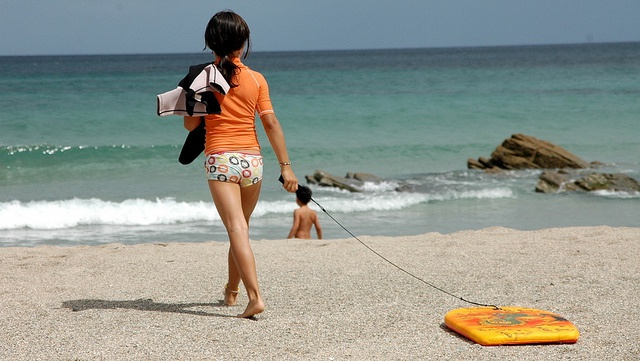Describe the objects in this image and their specific colors. I can see people in gray, black, tan, maroon, and brown tones, surfboard in gray, orange, gold, and red tones, and people in gray, salmon, black, brown, and maroon tones in this image. 